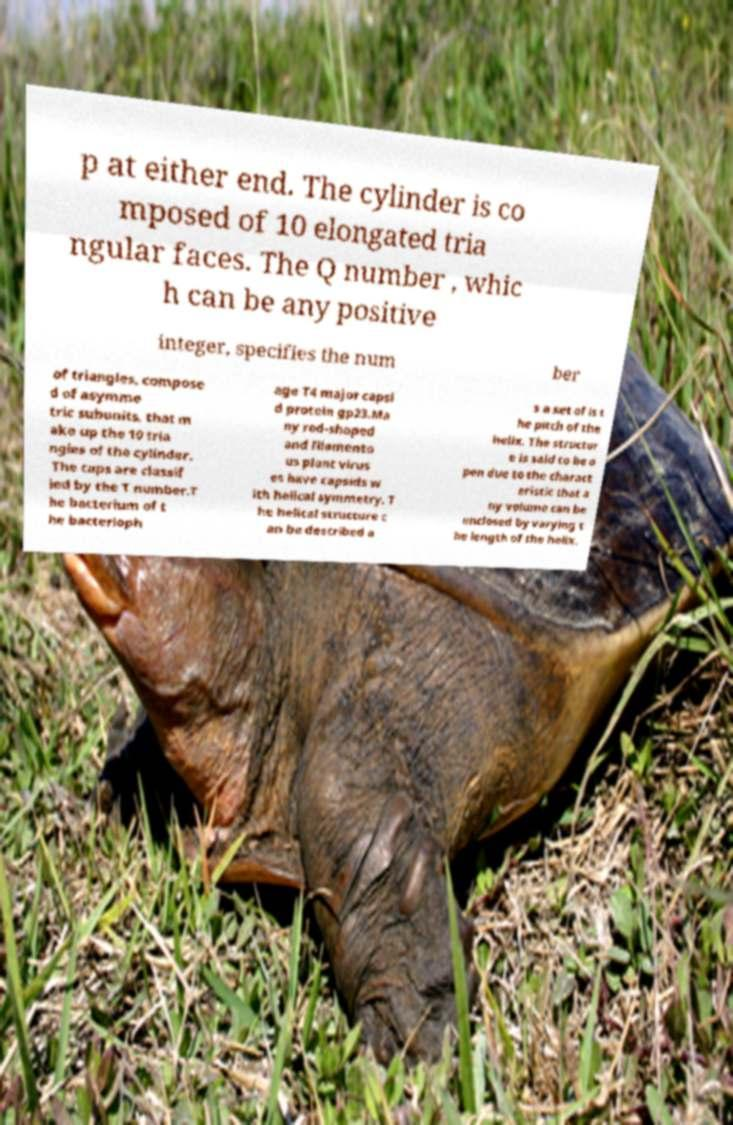There's text embedded in this image that I need extracted. Can you transcribe it verbatim? p at either end. The cylinder is co mposed of 10 elongated tria ngular faces. The Q number , whic h can be any positive integer, specifies the num ber of triangles, compose d of asymme tric subunits, that m ake up the 10 tria ngles of the cylinder. The caps are classif ied by the T number.T he bacterium of t he bacterioph age T4 major capsi d protein gp23.Ma ny rod-shaped and filamento us plant virus es have capsids w ith helical symmetry. T he helical structure c an be described a s a set of is t he pitch of the helix. The structur e is said to be o pen due to the charact eristic that a ny volume can be enclosed by varying t he length of the helix. 